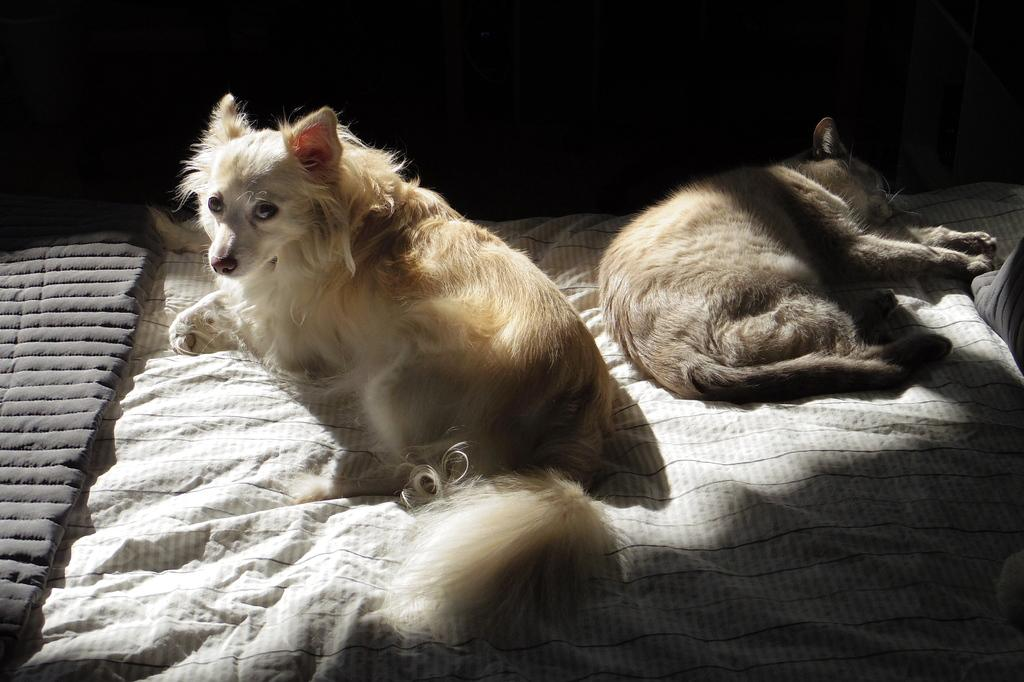What is the position of the dogs in the image? There is a dog sitting on the bed, and another dog is sleeping on the bed. How are the dogs arranged in relation to each other? The dogs are behind each other. What is present at the bottom of the bed? There is a blanket at the bottom of the bed. What type of glue is being used to hold the dogs together in the image? There is no glue present in the image, and the dogs are not being held together. 